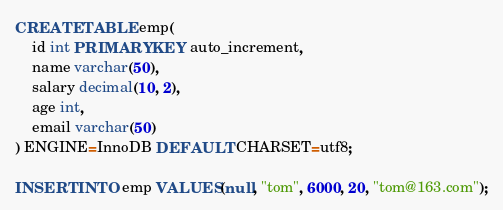<code> <loc_0><loc_0><loc_500><loc_500><_SQL_>
CREATE TABLE emp(
    id int PRIMARY KEY auto_increment,
    name varchar(50),
    salary decimal(10, 2),
    age int,
    email varchar(50)
) ENGINE=InnoDB DEFAULT CHARSET=utf8;

INSERT INTO emp VALUES(null, "tom", 6000, 20, "tom@163.com");</code> 